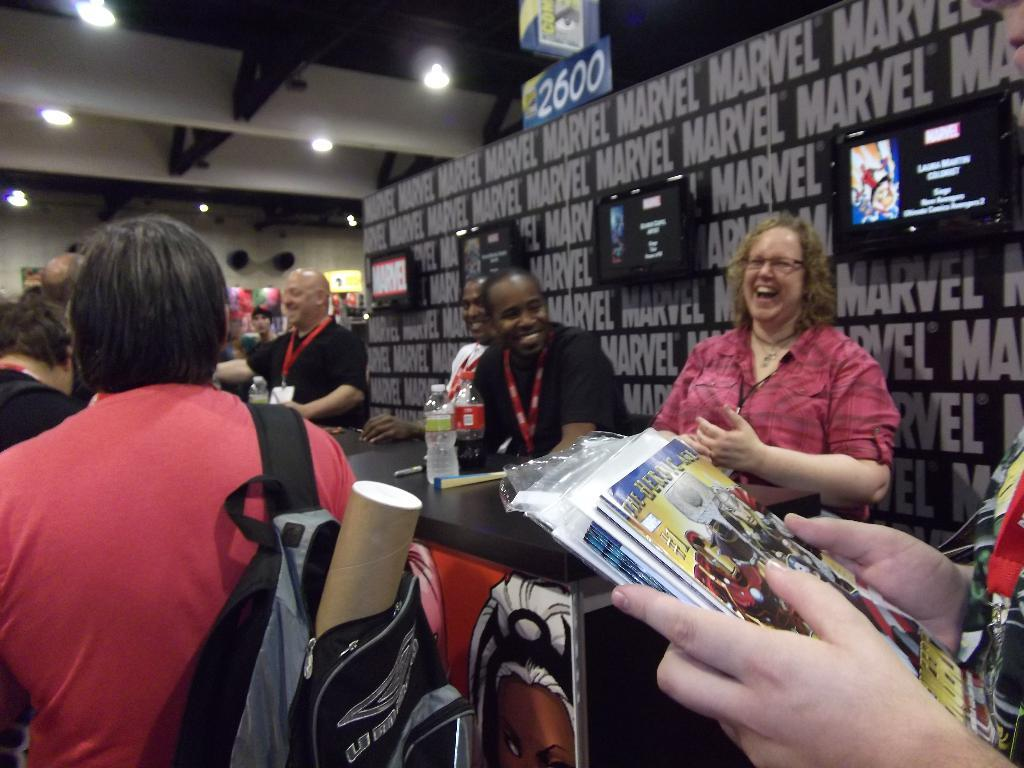<image>
Present a compact description of the photo's key features. People in line at a Marvel signing event. 